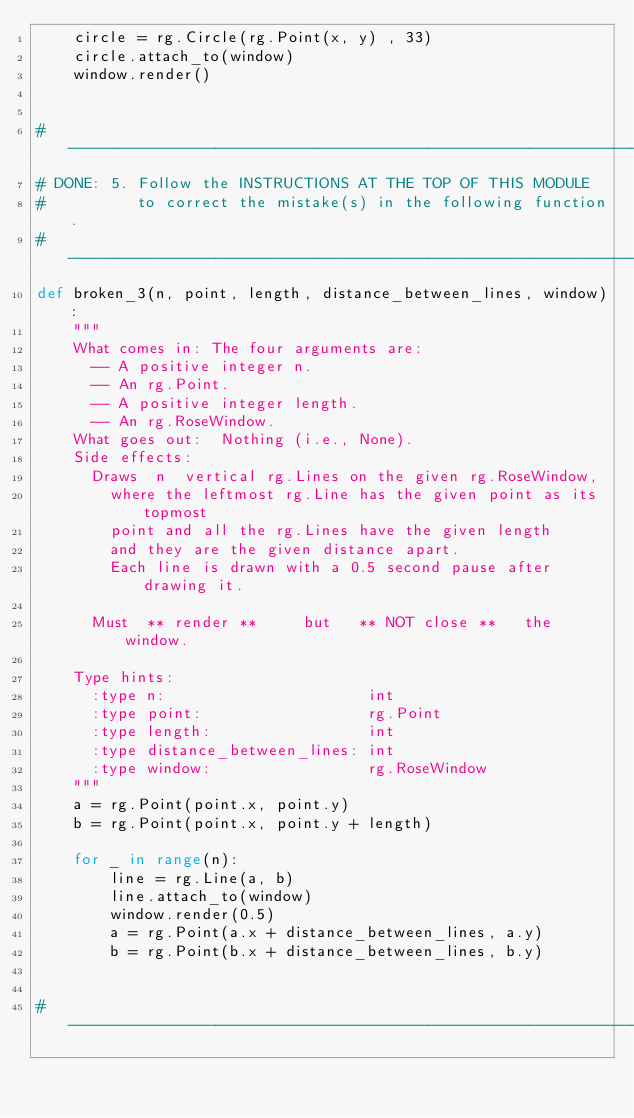Convert code to text. <code><loc_0><loc_0><loc_500><loc_500><_Python_>    circle = rg.Circle(rg.Point(x, y) , 33)
    circle.attach_to(window)
    window.render()


# -----------------------------------------------------------------------------
# DONE: 5. Follow the INSTRUCTIONS AT THE TOP OF THIS MODULE
#          to correct the mistake(s) in the following function.
# -----------------------------------------------------------------------------
def broken_3(n, point, length, distance_between_lines, window):
    """
    What comes in: The four arguments are:
      -- A positive integer n.
      -- An rg.Point.
      -- A positive integer length.
      -- An rg.RoseWindow.
    What goes out:  Nothing (i.e., None).
    Side effects:
      Draws  n  vertical rg.Lines on the given rg.RoseWindow,
        where the leftmost rg.Line has the given point as its topmost
        point and all the rg.Lines have the given length
        and they are the given distance apart.
        Each line is drawn with a 0.5 second pause after drawing it.

      Must  ** render **     but   ** NOT close **   the window.

    Type hints:
      :type n:                      int
      :type point:                  rg.Point
      :type length:                 int
      :type distance_between_lines: int
      :type window:                 rg.RoseWindow
    """
    a = rg.Point(point.x, point.y)
    b = rg.Point(point.x, point.y + length)

    for _ in range(n):
        line = rg.Line(a, b)
        line.attach_to(window)
        window.render(0.5)
        a = rg.Point(a.x + distance_between_lines, a.y)
        b = rg.Point(b.x + distance_between_lines, b.y)


# -----------------------------------------------------------------------------</code> 